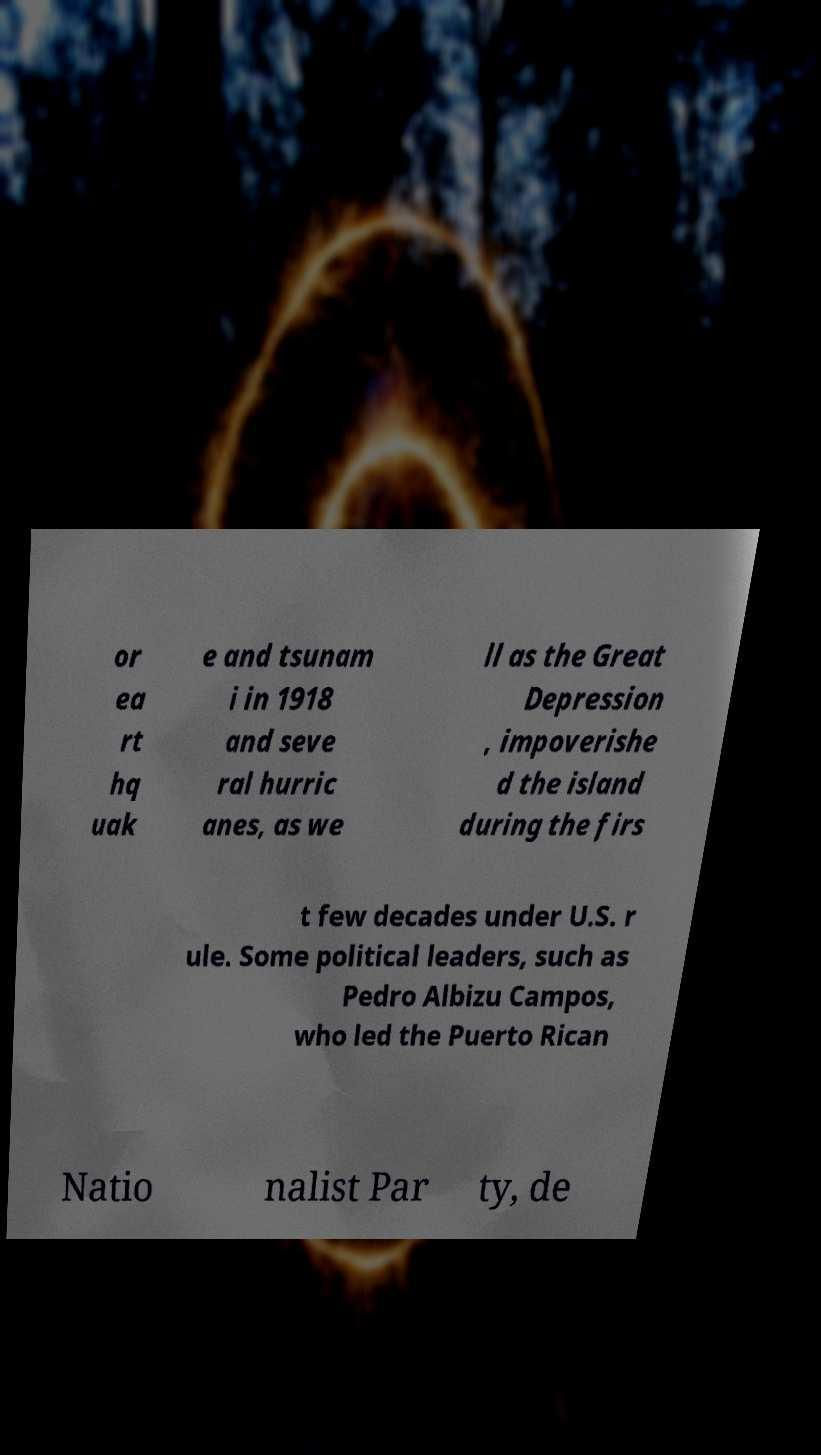I need the written content from this picture converted into text. Can you do that? or ea rt hq uak e and tsunam i in 1918 and seve ral hurric anes, as we ll as the Great Depression , impoverishe d the island during the firs t few decades under U.S. r ule. Some political leaders, such as Pedro Albizu Campos, who led the Puerto Rican Natio nalist Par ty, de 